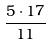Convert formula to latex. <formula><loc_0><loc_0><loc_500><loc_500>\frac { 5 \cdot 1 7 } { 1 1 }</formula> 